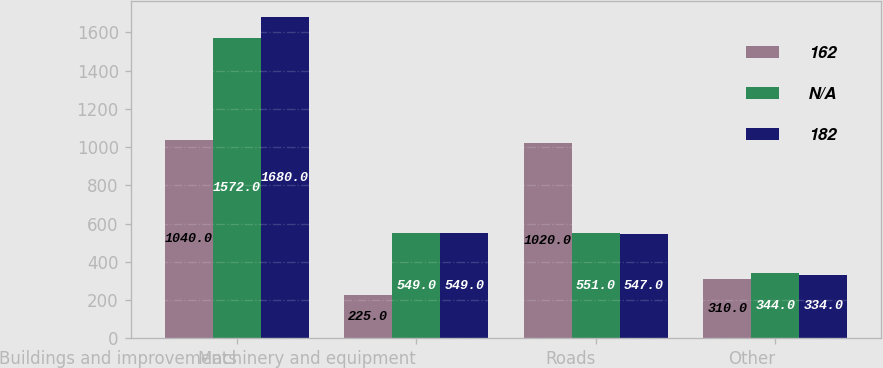<chart> <loc_0><loc_0><loc_500><loc_500><stacked_bar_chart><ecel><fcel>Buildings and improvements<fcel>Machinery and equipment<fcel>Roads<fcel>Other<nl><fcel>162<fcel>1040<fcel>225<fcel>1020<fcel>310<nl><fcel>nan<fcel>1572<fcel>549<fcel>551<fcel>344<nl><fcel>182<fcel>1680<fcel>549<fcel>547<fcel>334<nl></chart> 